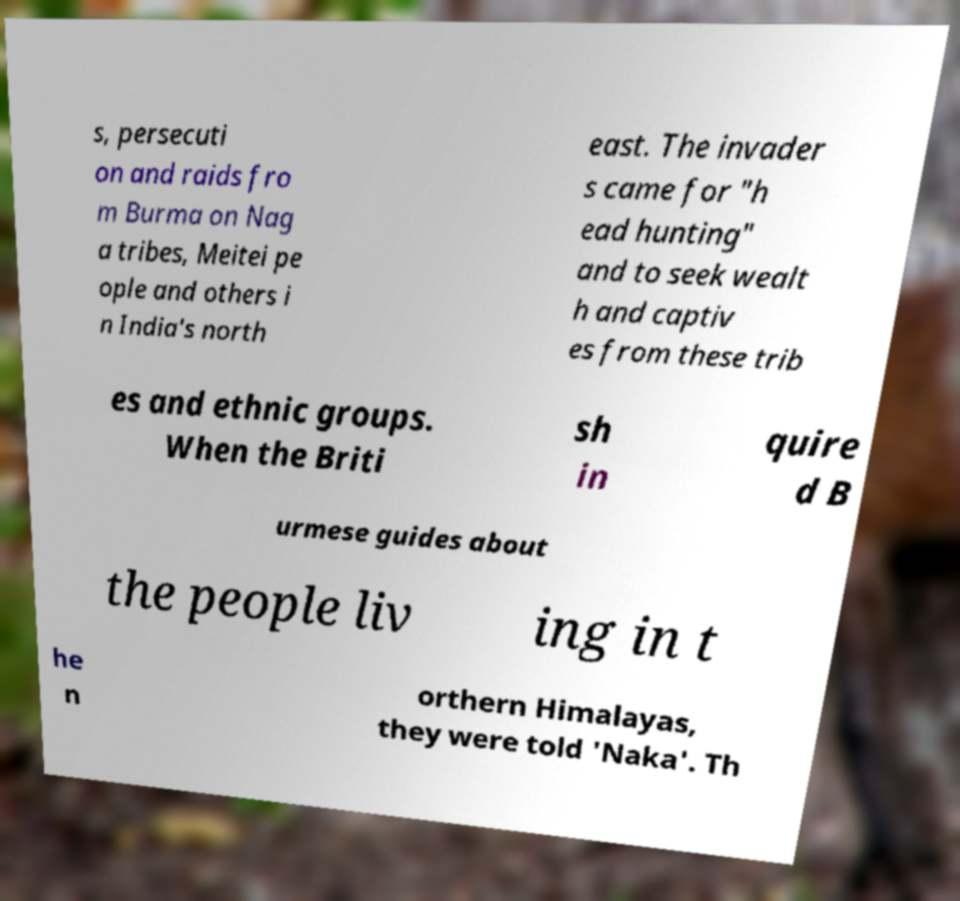What messages or text are displayed in this image? I need them in a readable, typed format. s, persecuti on and raids fro m Burma on Nag a tribes, Meitei pe ople and others i n India's north east. The invader s came for "h ead hunting" and to seek wealt h and captiv es from these trib es and ethnic groups. When the Briti sh in quire d B urmese guides about the people liv ing in t he n orthern Himalayas, they were told 'Naka'. Th 